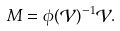<formula> <loc_0><loc_0><loc_500><loc_500>M = \phi ( \mathcal { V } ) ^ { - 1 } \mathcal { V } .</formula> 